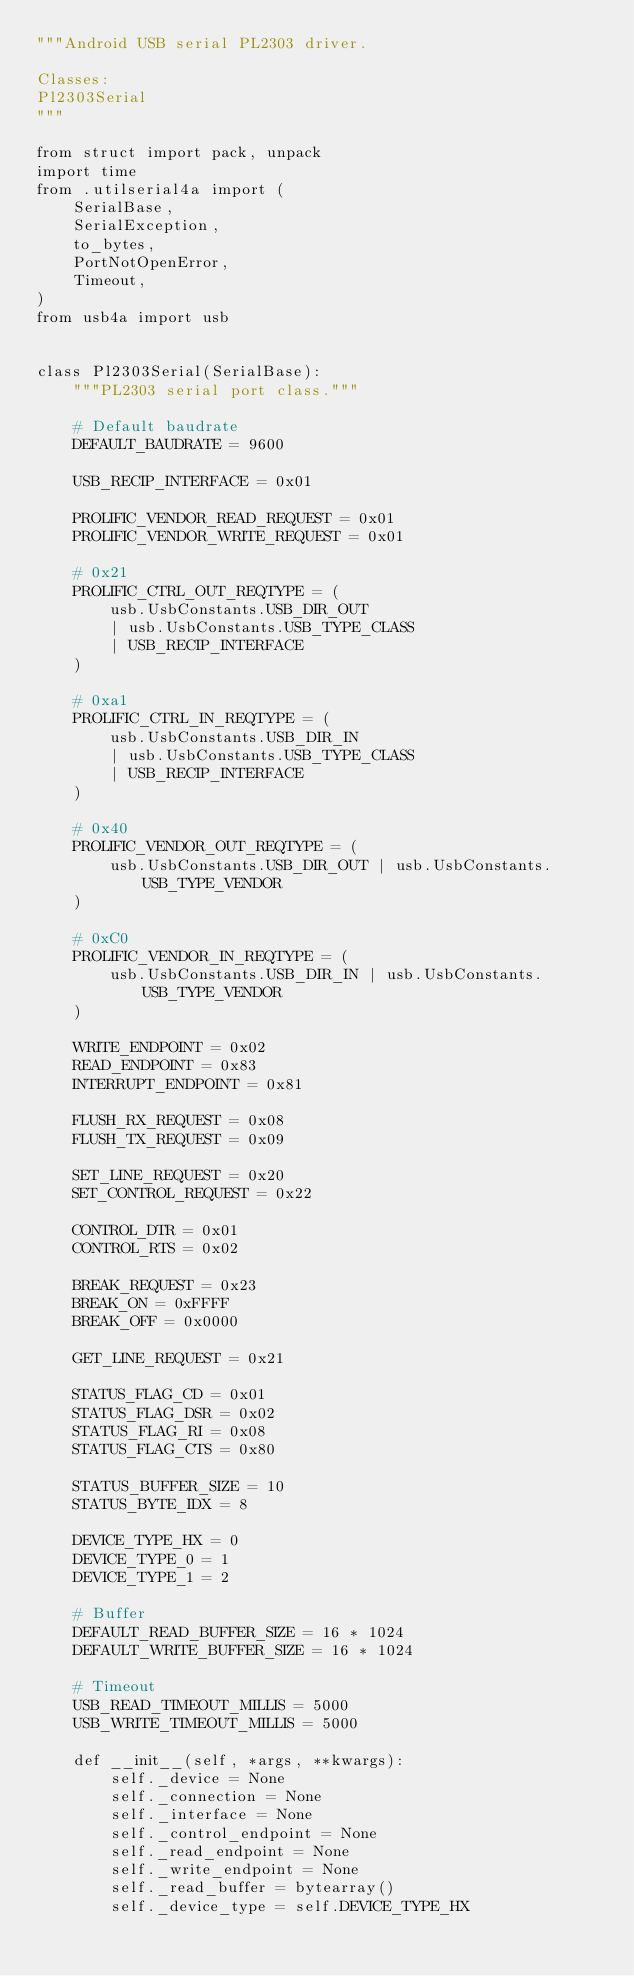Convert code to text. <code><loc_0><loc_0><loc_500><loc_500><_Python_>"""Android USB serial PL2303 driver.

Classes:
Pl2303Serial
"""

from struct import pack, unpack
import time
from .utilserial4a import (
    SerialBase,
    SerialException,
    to_bytes,
    PortNotOpenError,
    Timeout,
)
from usb4a import usb


class Pl2303Serial(SerialBase):
    """PL2303 serial port class."""

    # Default baudrate
    DEFAULT_BAUDRATE = 9600

    USB_RECIP_INTERFACE = 0x01

    PROLIFIC_VENDOR_READ_REQUEST = 0x01
    PROLIFIC_VENDOR_WRITE_REQUEST = 0x01

    # 0x21
    PROLIFIC_CTRL_OUT_REQTYPE = (
        usb.UsbConstants.USB_DIR_OUT
        | usb.UsbConstants.USB_TYPE_CLASS
        | USB_RECIP_INTERFACE
    )

    # 0xa1
    PROLIFIC_CTRL_IN_REQTYPE = (
        usb.UsbConstants.USB_DIR_IN
        | usb.UsbConstants.USB_TYPE_CLASS
        | USB_RECIP_INTERFACE
    )

    # 0x40
    PROLIFIC_VENDOR_OUT_REQTYPE = (
        usb.UsbConstants.USB_DIR_OUT | usb.UsbConstants.USB_TYPE_VENDOR
    )

    # 0xC0
    PROLIFIC_VENDOR_IN_REQTYPE = (
        usb.UsbConstants.USB_DIR_IN | usb.UsbConstants.USB_TYPE_VENDOR
    )

    WRITE_ENDPOINT = 0x02
    READ_ENDPOINT = 0x83
    INTERRUPT_ENDPOINT = 0x81

    FLUSH_RX_REQUEST = 0x08
    FLUSH_TX_REQUEST = 0x09

    SET_LINE_REQUEST = 0x20
    SET_CONTROL_REQUEST = 0x22

    CONTROL_DTR = 0x01
    CONTROL_RTS = 0x02

    BREAK_REQUEST = 0x23
    BREAK_ON = 0xFFFF
    BREAK_OFF = 0x0000

    GET_LINE_REQUEST = 0x21

    STATUS_FLAG_CD = 0x01
    STATUS_FLAG_DSR = 0x02
    STATUS_FLAG_RI = 0x08
    STATUS_FLAG_CTS = 0x80

    STATUS_BUFFER_SIZE = 10
    STATUS_BYTE_IDX = 8

    DEVICE_TYPE_HX = 0
    DEVICE_TYPE_0 = 1
    DEVICE_TYPE_1 = 2

    # Buffer
    DEFAULT_READ_BUFFER_SIZE = 16 * 1024
    DEFAULT_WRITE_BUFFER_SIZE = 16 * 1024

    # Timeout
    USB_READ_TIMEOUT_MILLIS = 5000
    USB_WRITE_TIMEOUT_MILLIS = 5000

    def __init__(self, *args, **kwargs):
        self._device = None
        self._connection = None
        self._interface = None
        self._control_endpoint = None
        self._read_endpoint = None
        self._write_endpoint = None
        self._read_buffer = bytearray()
        self._device_type = self.DEVICE_TYPE_HX</code> 